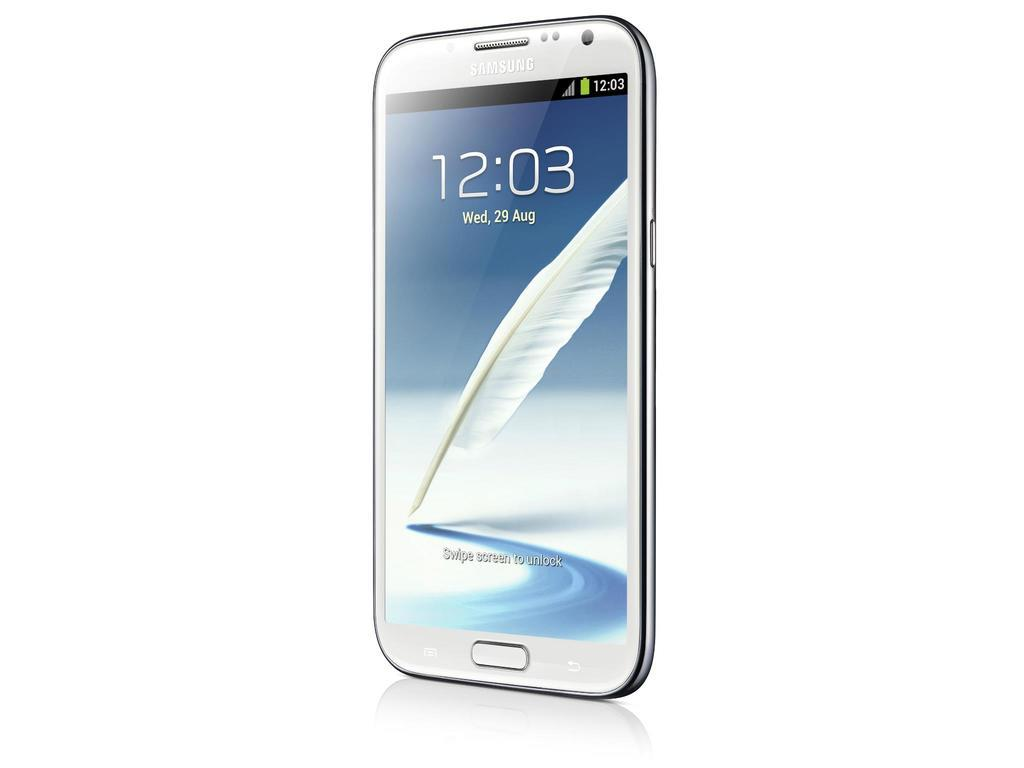<image>
Create a compact narrative representing the image presented. The front of a Samsung phone shows the time as 12:03. 